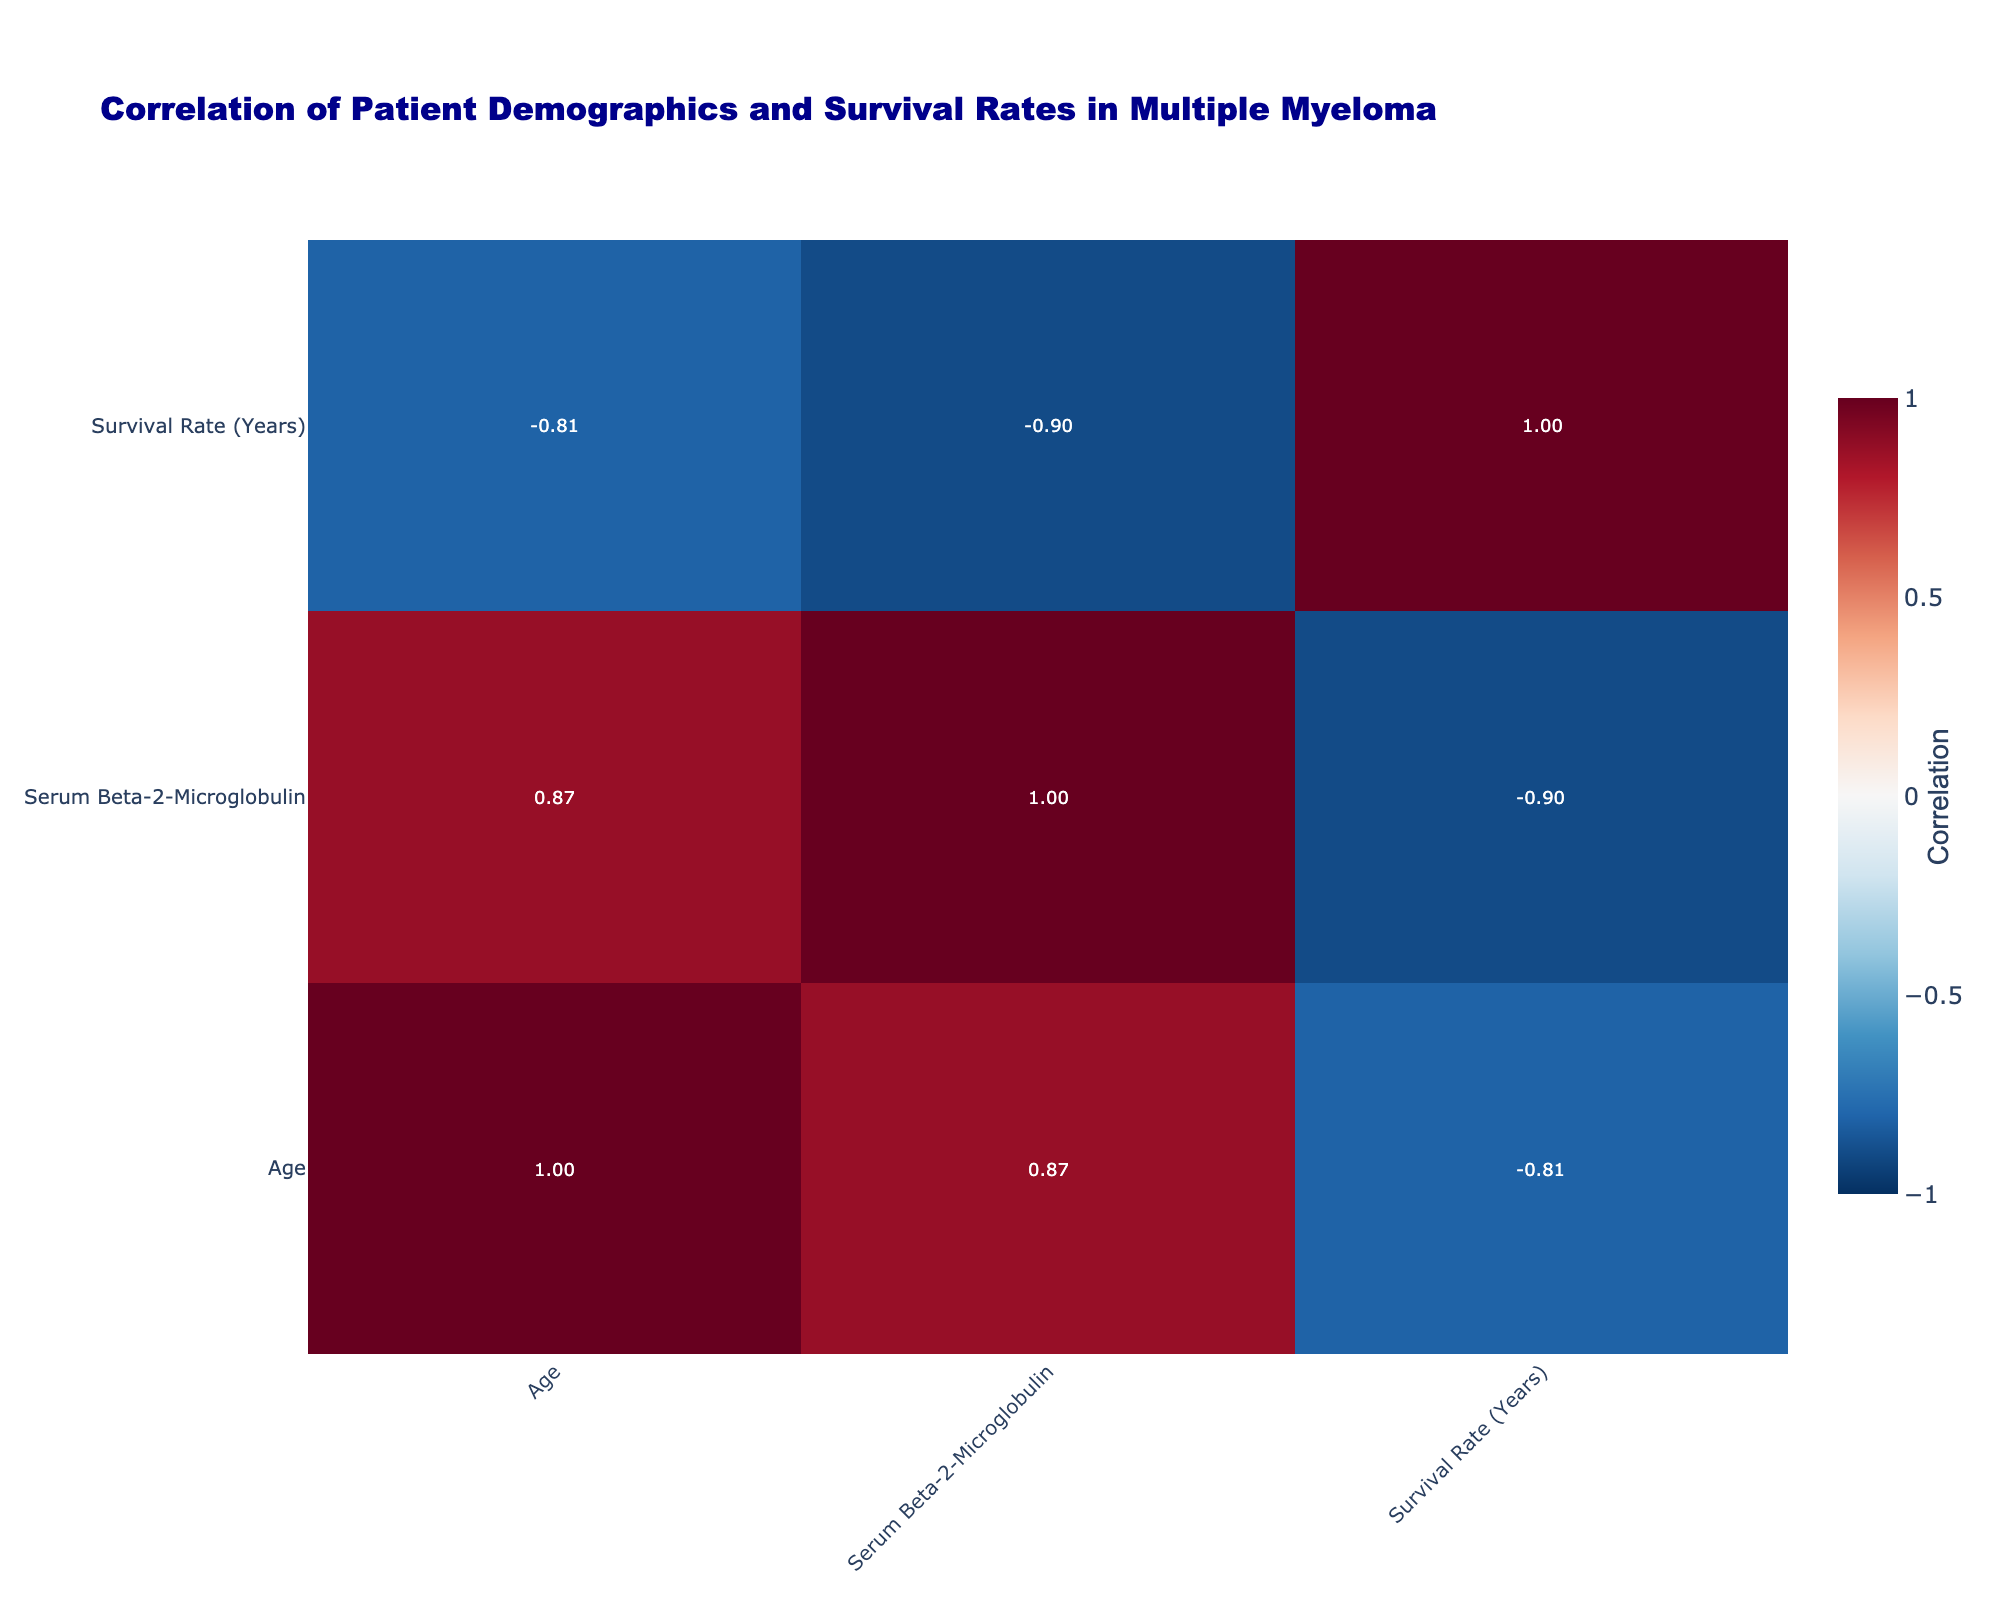What is the survival rate for the patient diagnosed at Stage IV? The survival rate for the patient diagnosed at Stage IV is 1 year, as evidenced by the data showing that the patient aged 80, female, with a serum Beta-2-Microglobulin of 6.8 and hypertensive, exhibits a survival rate of 1 year.
Answer: 1 year Which age group has the highest survival rate? To determine which age group has the highest survival rate, we compare the individual survival rates across ages. The highest survival rate is seen in the patient aged 60 with a survival rate of 8 years.
Answer: 60 Is there a correlation between gender and survival rate? The correlation value indicates a weak negative correlation between gender and survival rate, meaning that gender does not significantly influence survival rates based on the table data.
Answer: No What is the median survival rate among all patients? To find the median, we need to sort the survival rates: 0.5, 1, 3, 3, 4, 4, 5, 5, 6, 7, 8. The median is the average of the two middle values (4 and 4) when arranged, giving (4 + 4) / 2 = 4.
Answer: 4 How does the presence of comorbidities affect the survival rate in patients? Patients with comorbidities show lower survival rates on average. For example, the patient with chronic kidney disease has a survival rate of 0.5 years, while multiple patients without comorbidities have higher survival rates ranging from 3 to 8 years.
Answer: Lower survival rates What is the average serum Beta-2-Microglobulin level for patients receiving chemotherapy? Calculating the serum Beta-2-Microglobulin levels for patients receiving chemotherapy: 3.5, 4.7, 1.9. The total is 10.1, and there are 3 patients, so the average is 10.1 / 3 ≈ 3.37.
Answer: 3.37 